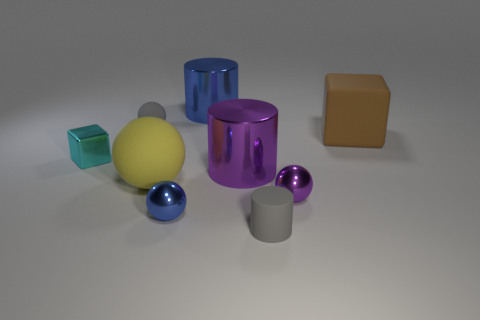Can you guess the material of the yellow sphere? The yellow sphere, with its smooth and even texture and the way it reflects light, could be interpreted as being made of plastic or a polished ceramic in a realistic setting. 